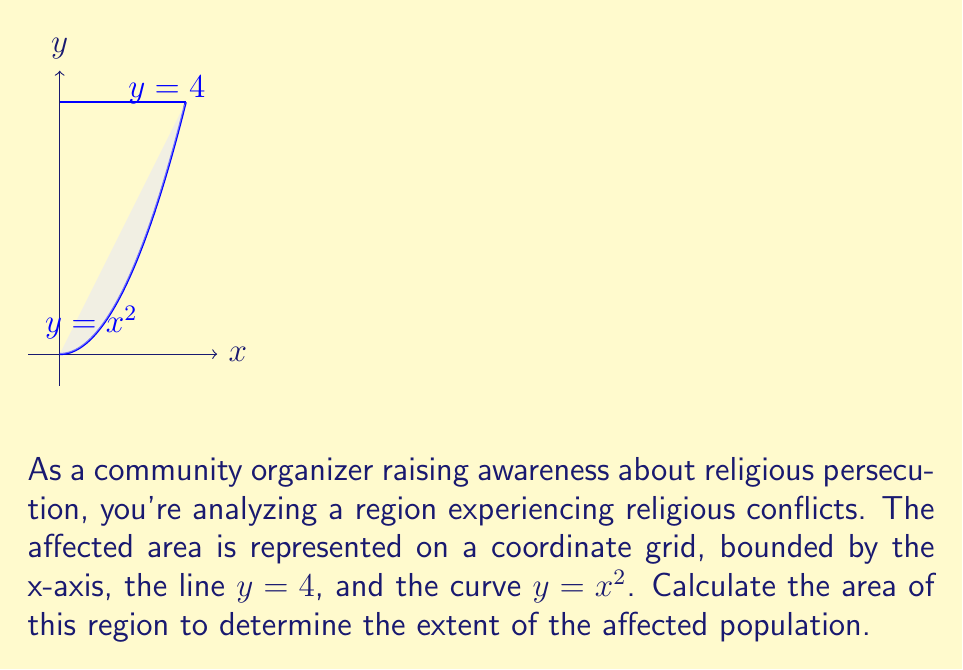Give your solution to this math problem. To find the area of the region, we need to use definite integration. The steps are as follows:

1) The region is bounded by $y = x^2$ from below and $y = 4$ from above. We need to find the points of intersection of these two functions:

   $x^2 = 4$
   $x = \pm 2$

   The region extends from $x = 0$ to $x = 2$ on the x-axis.

2) The area can be calculated by integrating the difference between the upper and lower functions:

   $$ A = \int_0^2 (4 - x^2) dx $$

3) Evaluate the integral:

   $$ A = \left[4x - \frac{x^3}{3}\right]_0^2 $$

4) Calculate the difference:

   $$ A = \left(8 - \frac{8}{3}\right) - \left(0 - 0\right) $$

5) Simplify:

   $$ A = 8 - \frac{8}{3} = \frac{24}{3} - \frac{8}{3} = \frac{16}{3} $$

Therefore, the area of the region is $\frac{16}{3}$ square units.
Answer: $\frac{16}{3}$ square units 